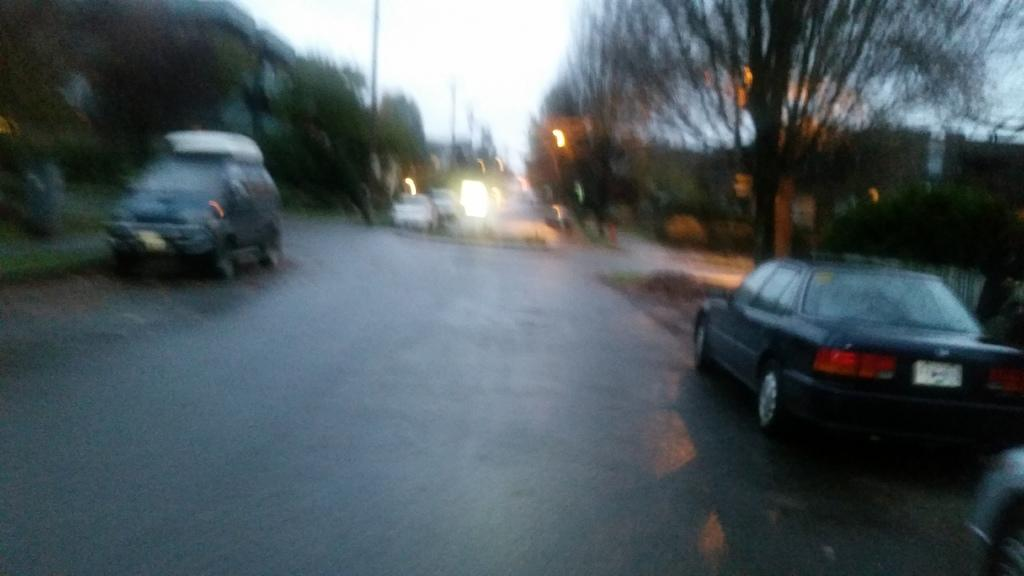What can be seen on the road in the image? There are vehicles on the road in the image. What type of natural feature is visible in the image? There is a group of trees visible in the image. What are the tall, thin structures in the image? There are poles in the image. What is visible above the ground in the image? The sky is visible in the image. What company produces the vehicles seen in the image? The provided facts do not mention any specific company, and there is no information about the vehicles' production in the image. How many prints of the image are available for purchase? The image is not a print, and there is no information about purchasing the image. 